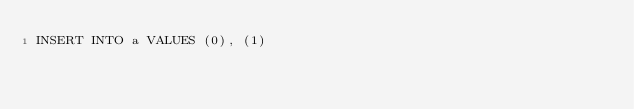<code> <loc_0><loc_0><loc_500><loc_500><_SQL_>INSERT INTO a VALUES (0), (1)
</code> 